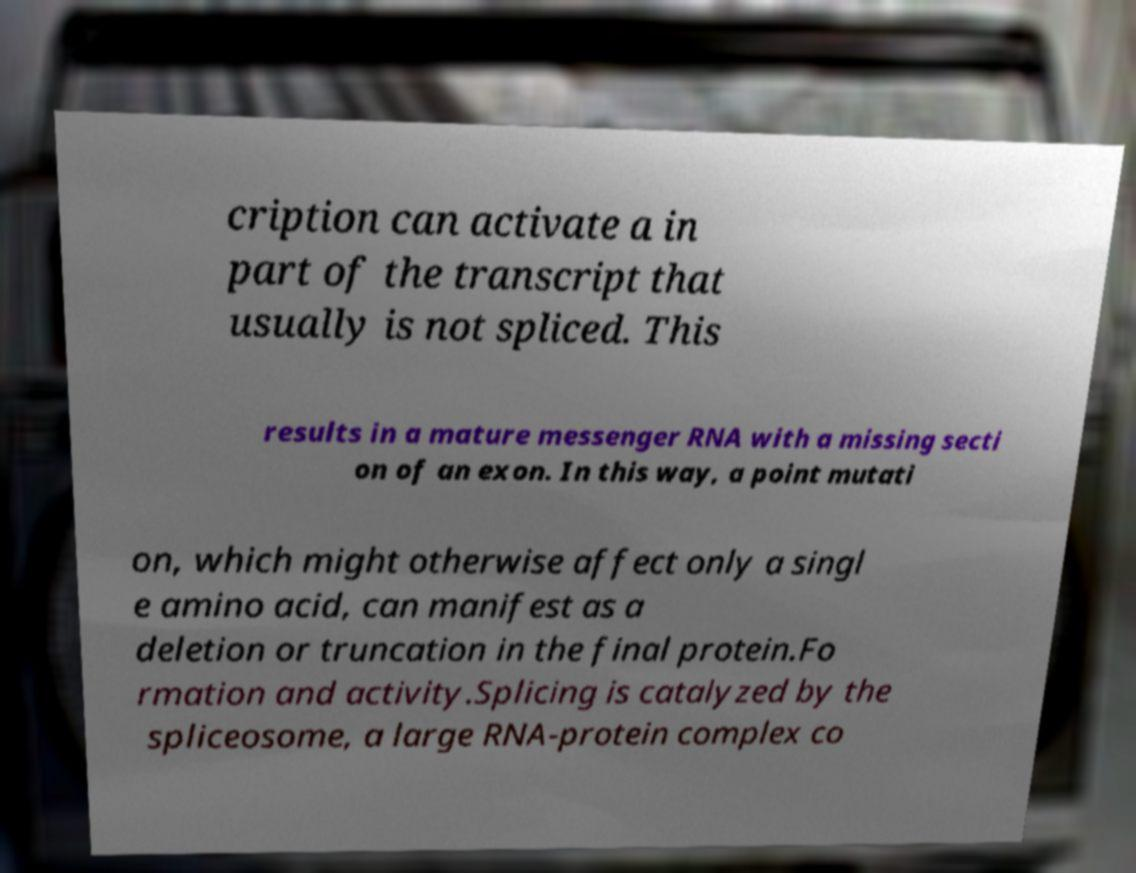I need the written content from this picture converted into text. Can you do that? cription can activate a in part of the transcript that usually is not spliced. This results in a mature messenger RNA with a missing secti on of an exon. In this way, a point mutati on, which might otherwise affect only a singl e amino acid, can manifest as a deletion or truncation in the final protein.Fo rmation and activity.Splicing is catalyzed by the spliceosome, a large RNA-protein complex co 